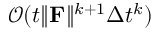<formula> <loc_0><loc_0><loc_500><loc_500>\mathcal { O } ( t \| \mathbf F \| ^ { k + 1 } \Delta t ^ { k } )</formula> 